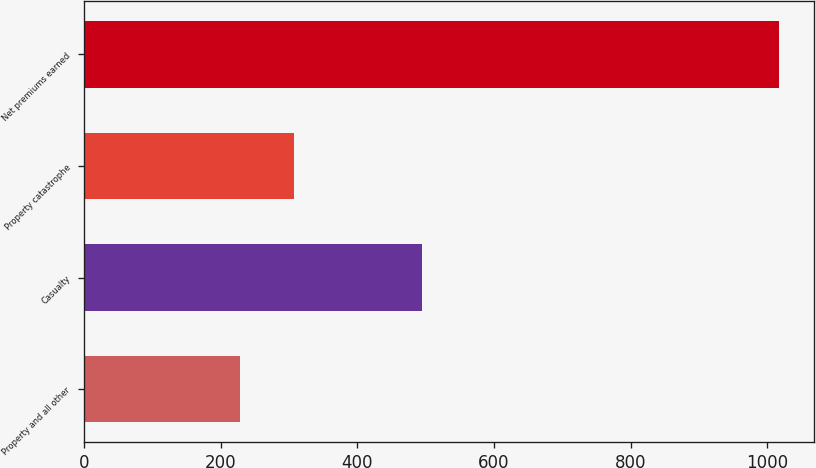Convert chart. <chart><loc_0><loc_0><loc_500><loc_500><bar_chart><fcel>Property and all other<fcel>Casualty<fcel>Property catastrophe<fcel>Net premiums earned<nl><fcel>229<fcel>494<fcel>307.8<fcel>1017<nl></chart> 